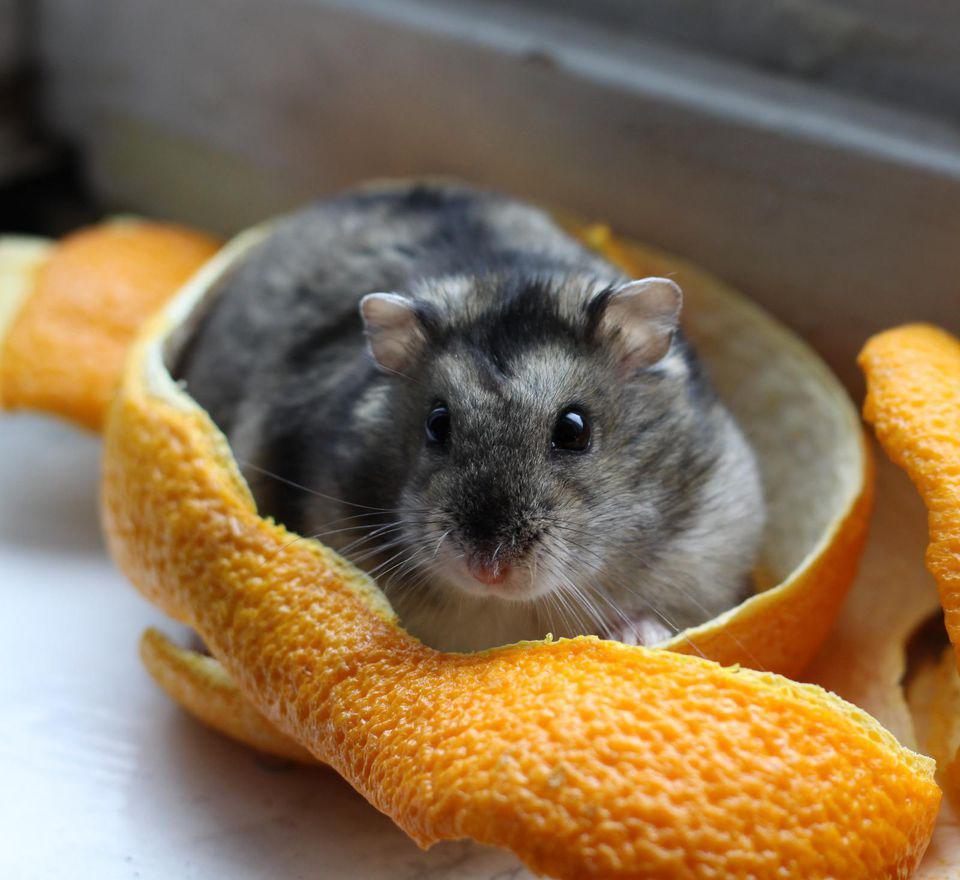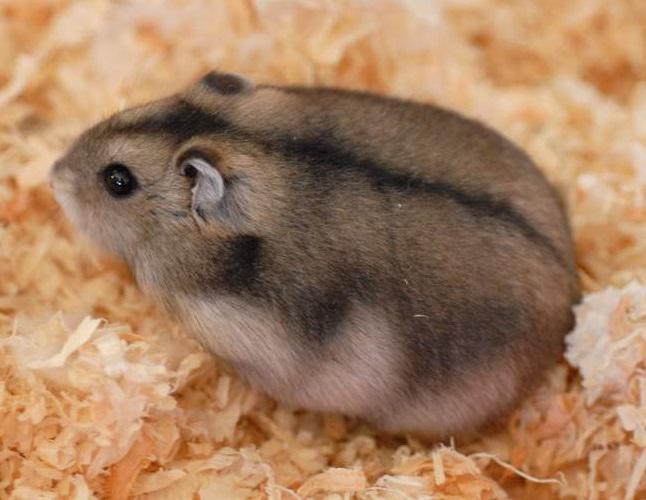The first image is the image on the left, the second image is the image on the right. Evaluate the accuracy of this statement regarding the images: "All the rodents are sitting on a white surface.". Is it true? Answer yes or no. No. The first image is the image on the left, the second image is the image on the right. Evaluate the accuracy of this statement regarding the images: "An image shows at least one pet rodent by a piece of bright orange food.". Is it true? Answer yes or no. Yes. 